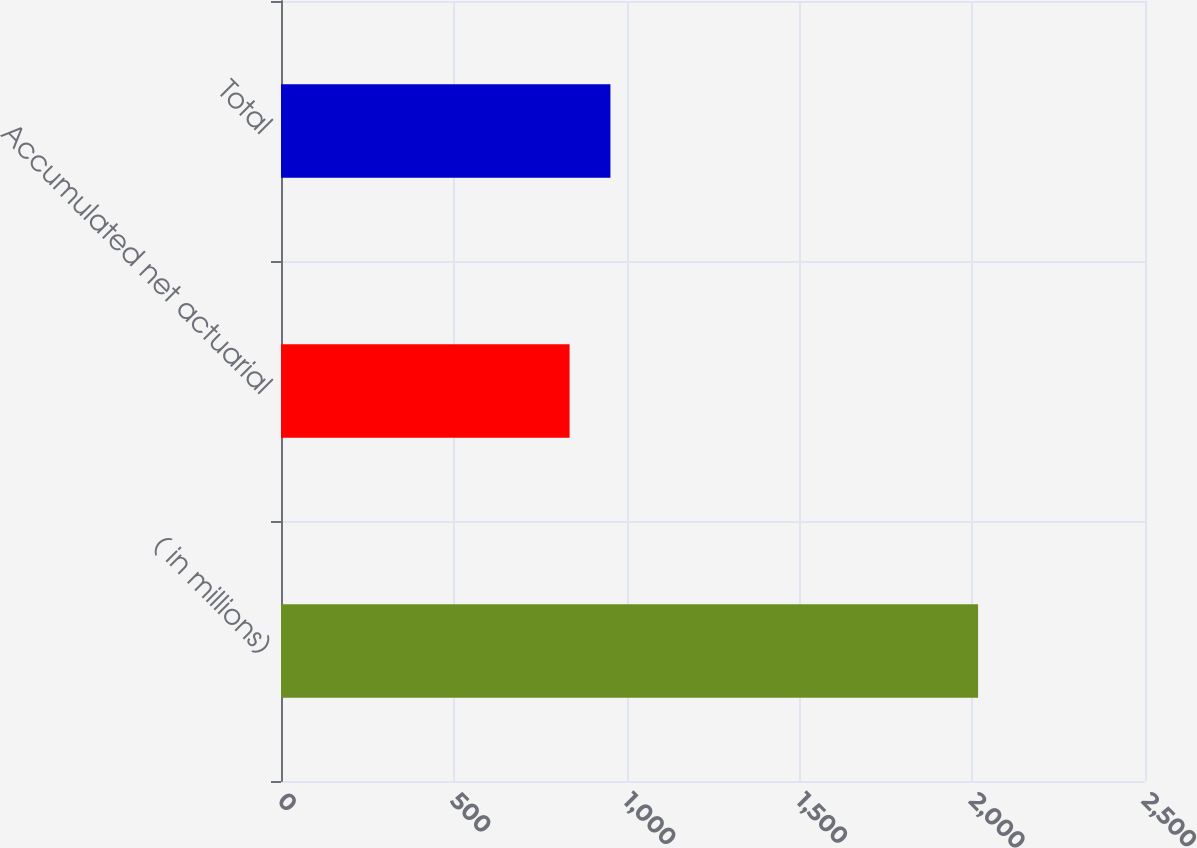Convert chart. <chart><loc_0><loc_0><loc_500><loc_500><bar_chart><fcel>( in millions)<fcel>Accumulated net actuarial<fcel>Total<nl><fcel>2017<fcel>835<fcel>953.2<nl></chart> 